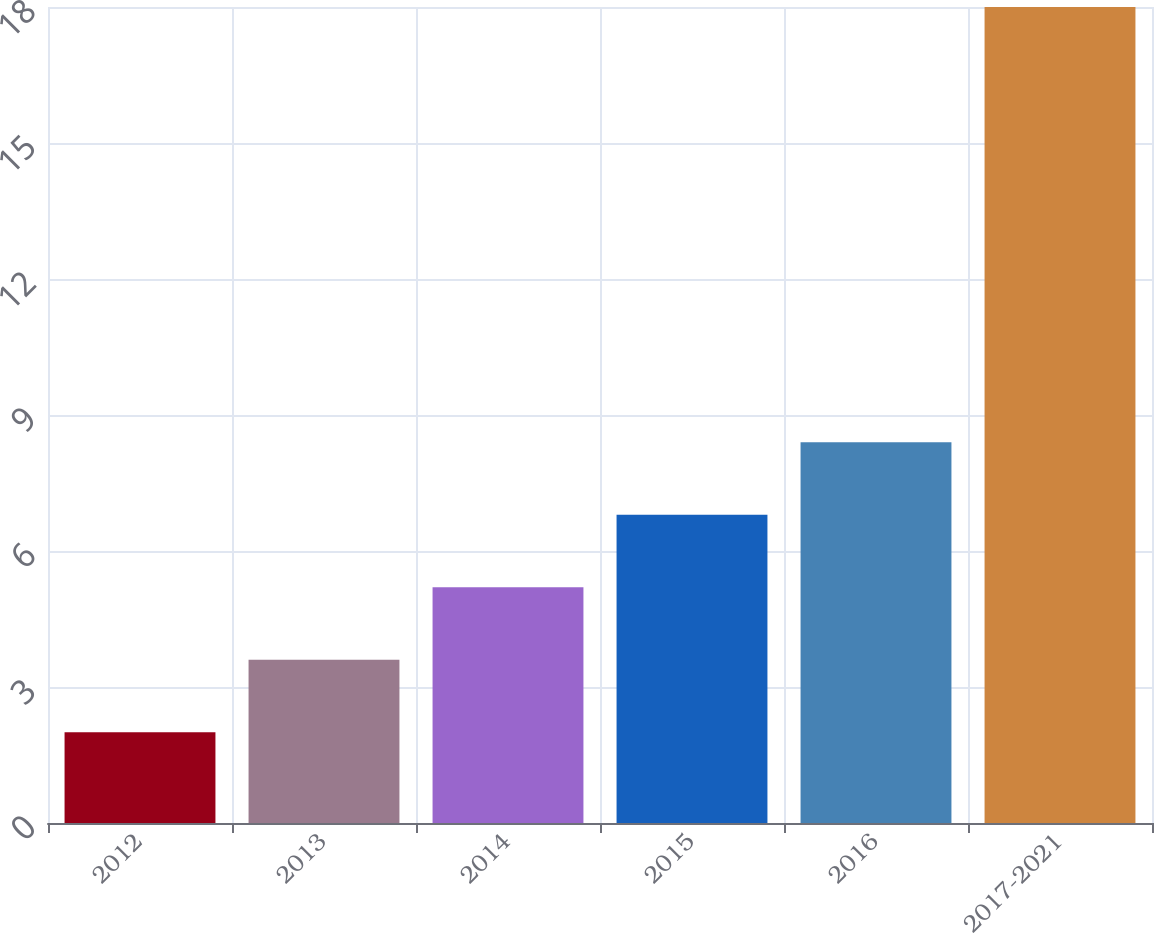Convert chart to OTSL. <chart><loc_0><loc_0><loc_500><loc_500><bar_chart><fcel>2012<fcel>2013<fcel>2014<fcel>2015<fcel>2016<fcel>2017-2021<nl><fcel>2<fcel>3.6<fcel>5.2<fcel>6.8<fcel>8.4<fcel>18<nl></chart> 